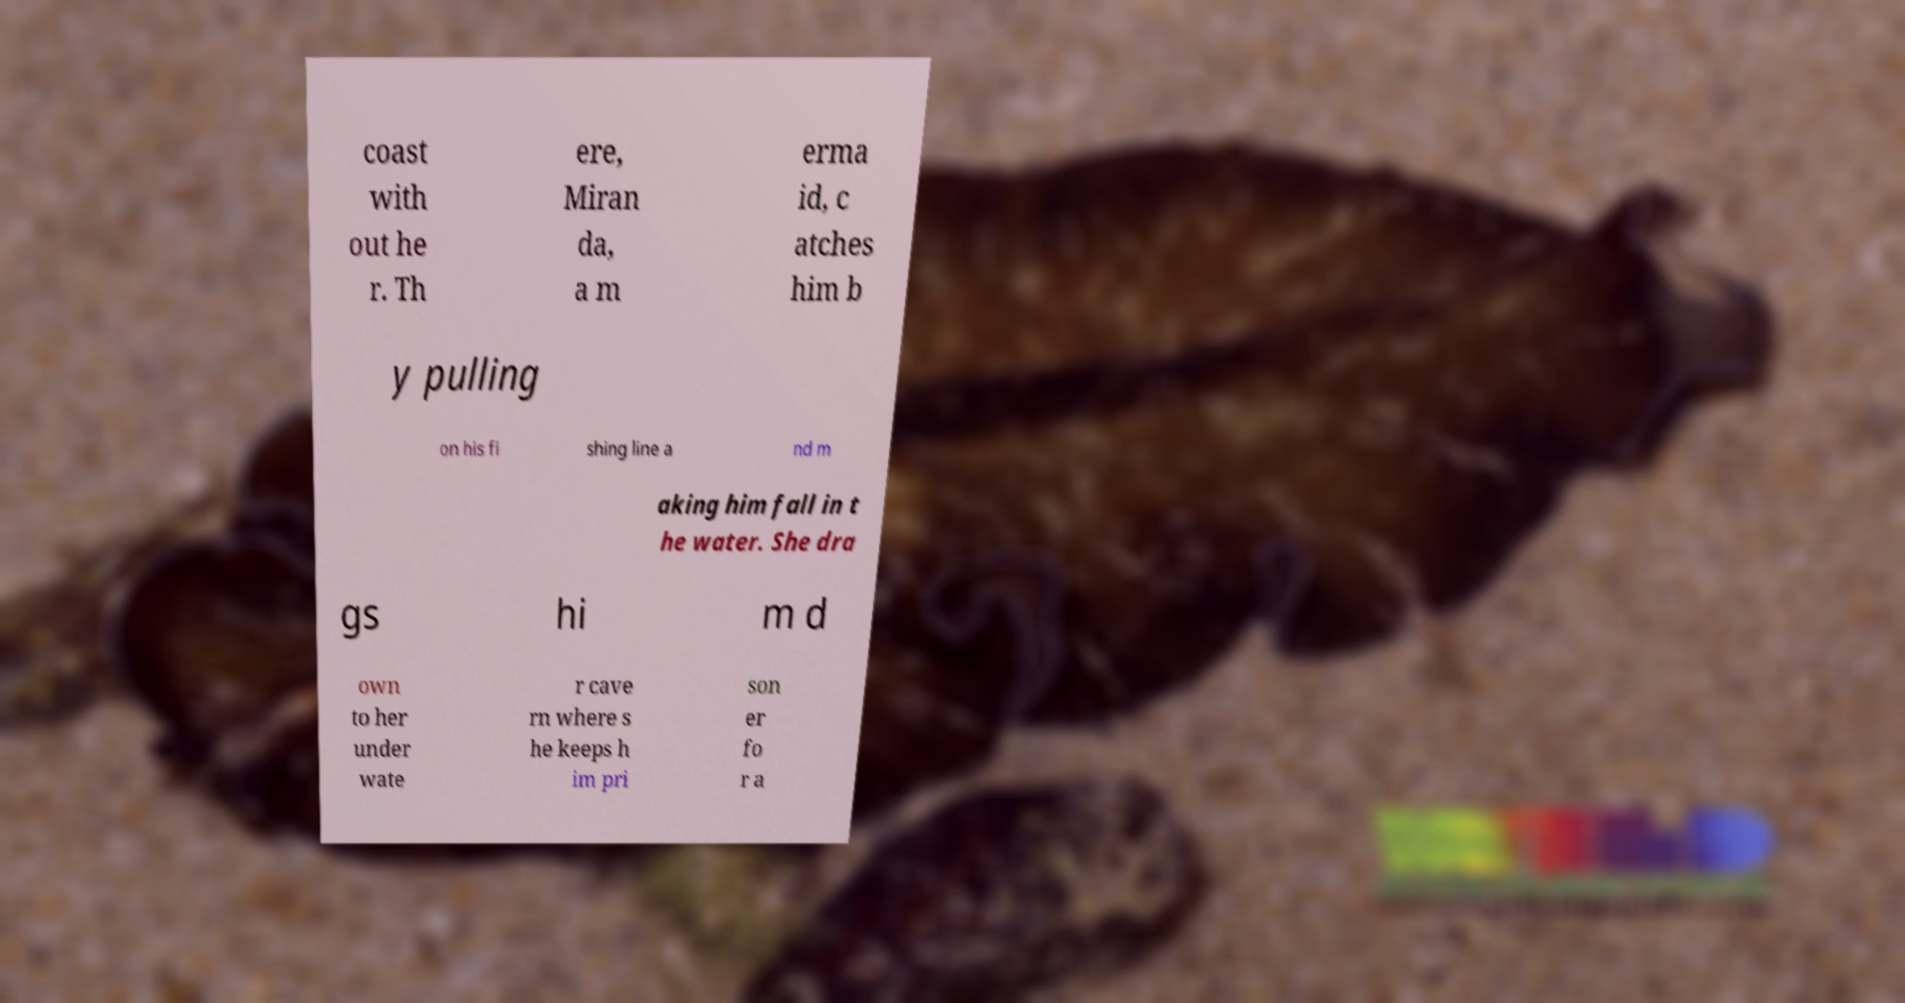What messages or text are displayed in this image? I need them in a readable, typed format. coast with out he r. Th ere, Miran da, a m erma id, c atches him b y pulling on his fi shing line a nd m aking him fall in t he water. She dra gs hi m d own to her under wate r cave rn where s he keeps h im pri son er fo r a 